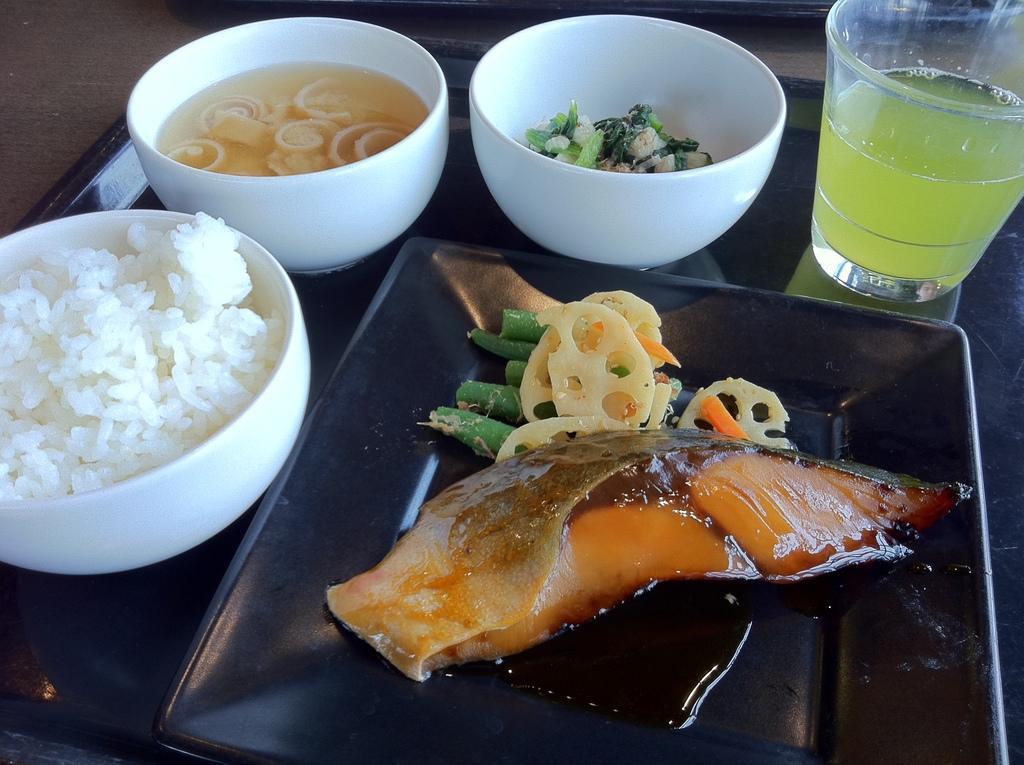Can you describe this image briefly? This picture shows a glass with a drink and few bowls with food and a plate with meat in it, All these bowls, plate and glass are placed in the tray on the table. 